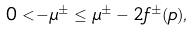Convert formula to latex. <formula><loc_0><loc_0><loc_500><loc_500>0 < - \mu ^ { \pm } \leq \mu ^ { \pm } - 2 f ^ { \pm } ( p ) ,</formula> 